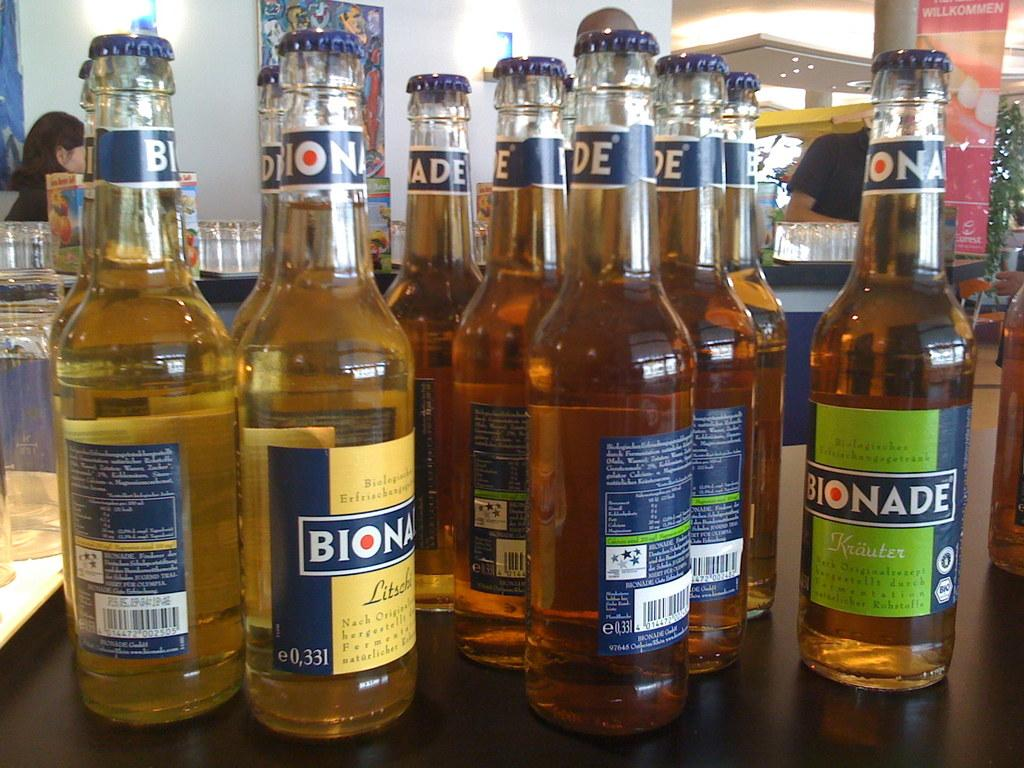<image>
Write a terse but informative summary of the picture. A multitude of Bionade bottles sit on a counter in a restaurant. 